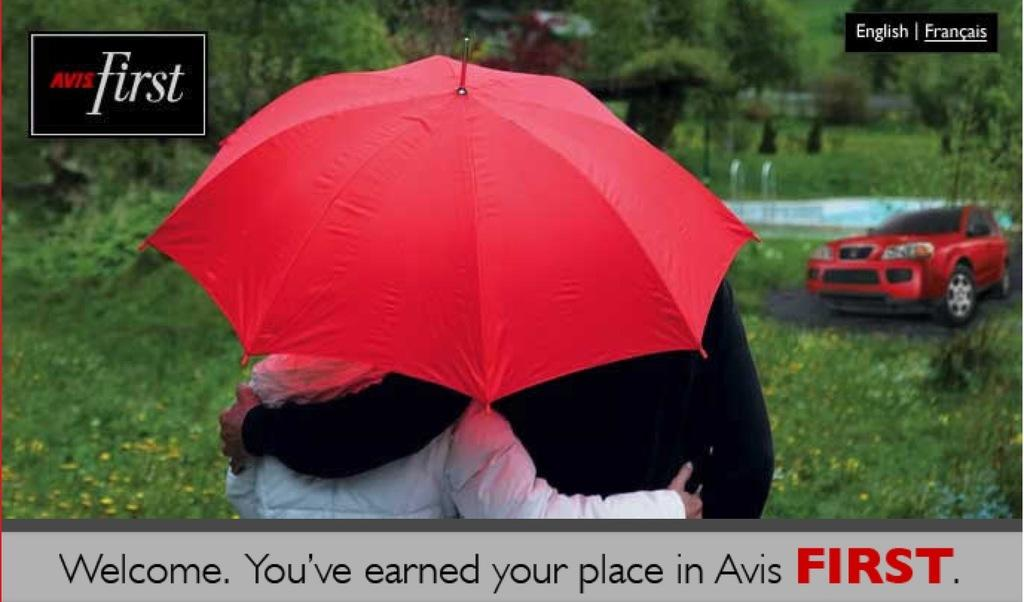How many people are in the image? There are two people in the image. What are the two people doing? The two people are holding each other. What can be seen in the image that provides protection from the rain? There is a red color umbrella in the image. What is visible in the background of the image? There is a car, plants, trees, and text in the background of the image. What type of donkey can be seen in the image? There is no donkey present in the image. How many fifths are visible in the image? The concept of "fifths" does not apply to the image, as it is not related to fractions or divisions. 